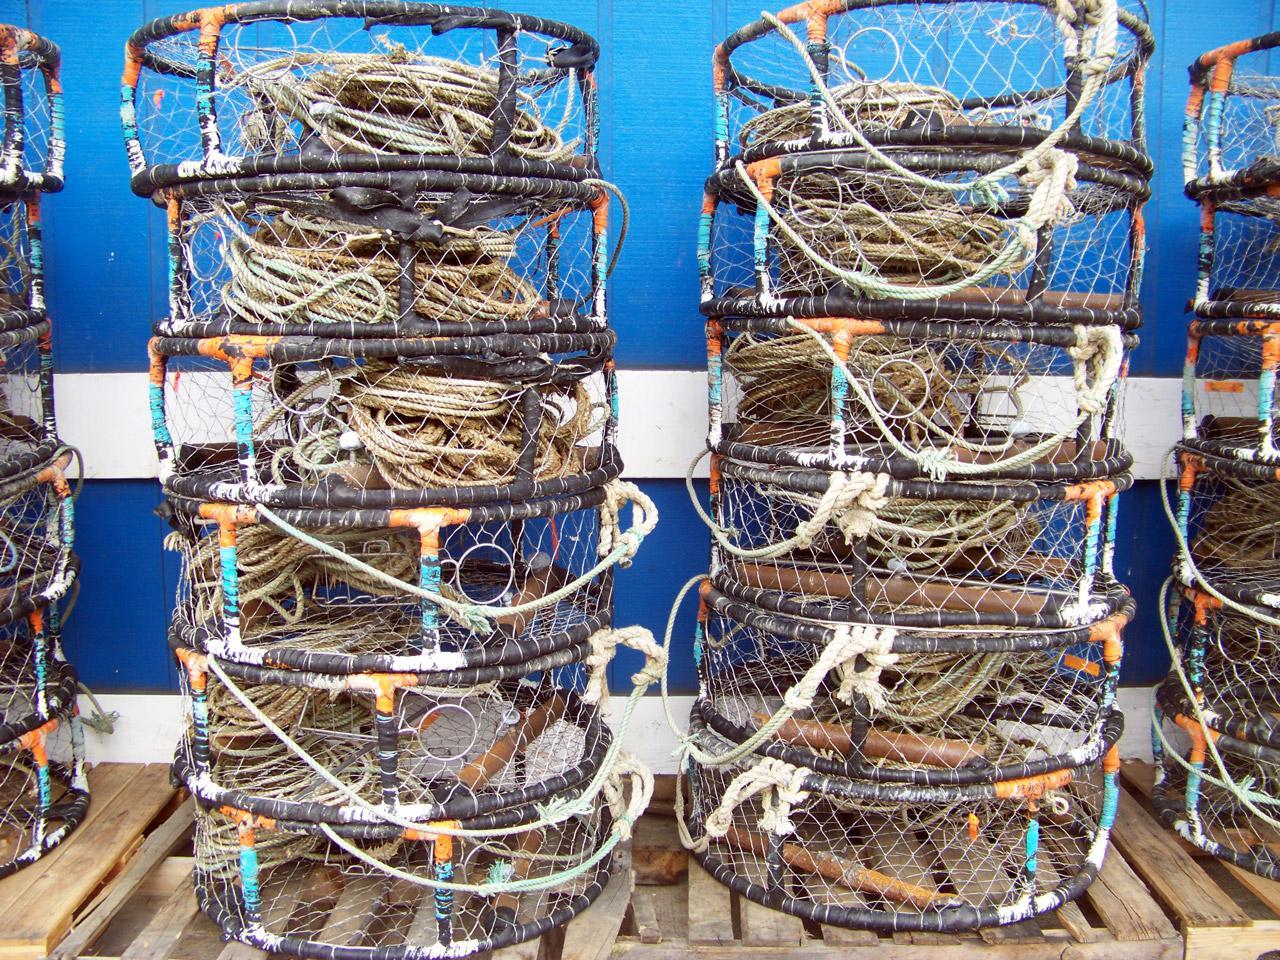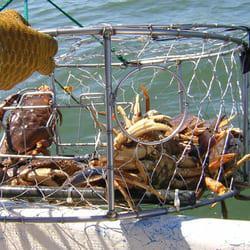The first image is the image on the left, the second image is the image on the right. Considering the images on both sides, is "All the crabs are in cages." valid? Answer yes or no. Yes. The first image is the image on the left, the second image is the image on the right. For the images shown, is this caption "All of the baskets holding the crabs are circular." true? Answer yes or no. Yes. 